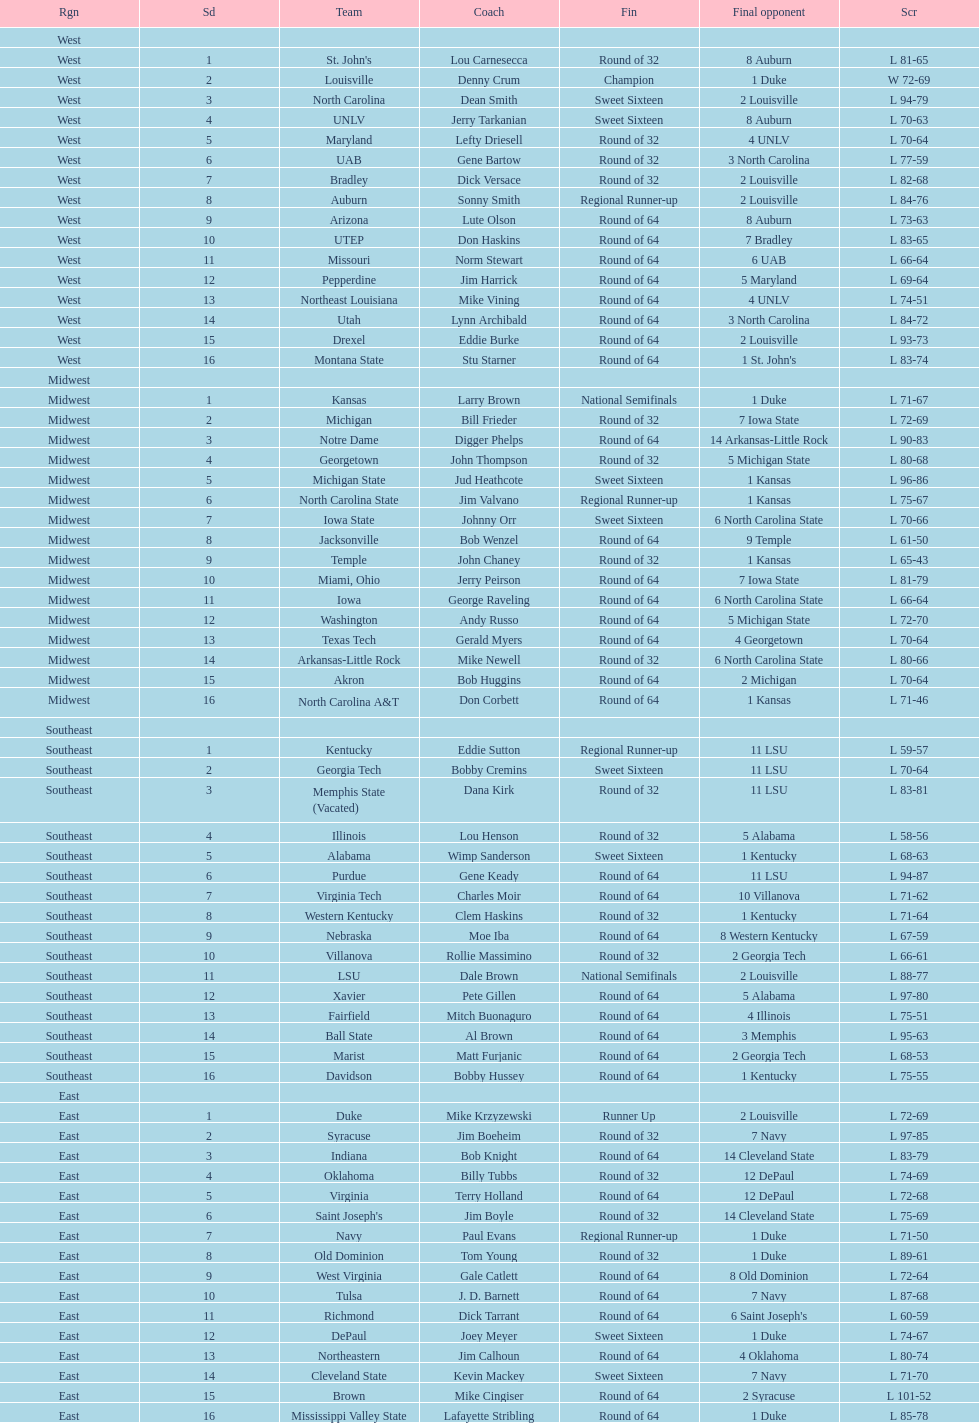What team finished at the top of all else and was finished as champions? Louisville. 